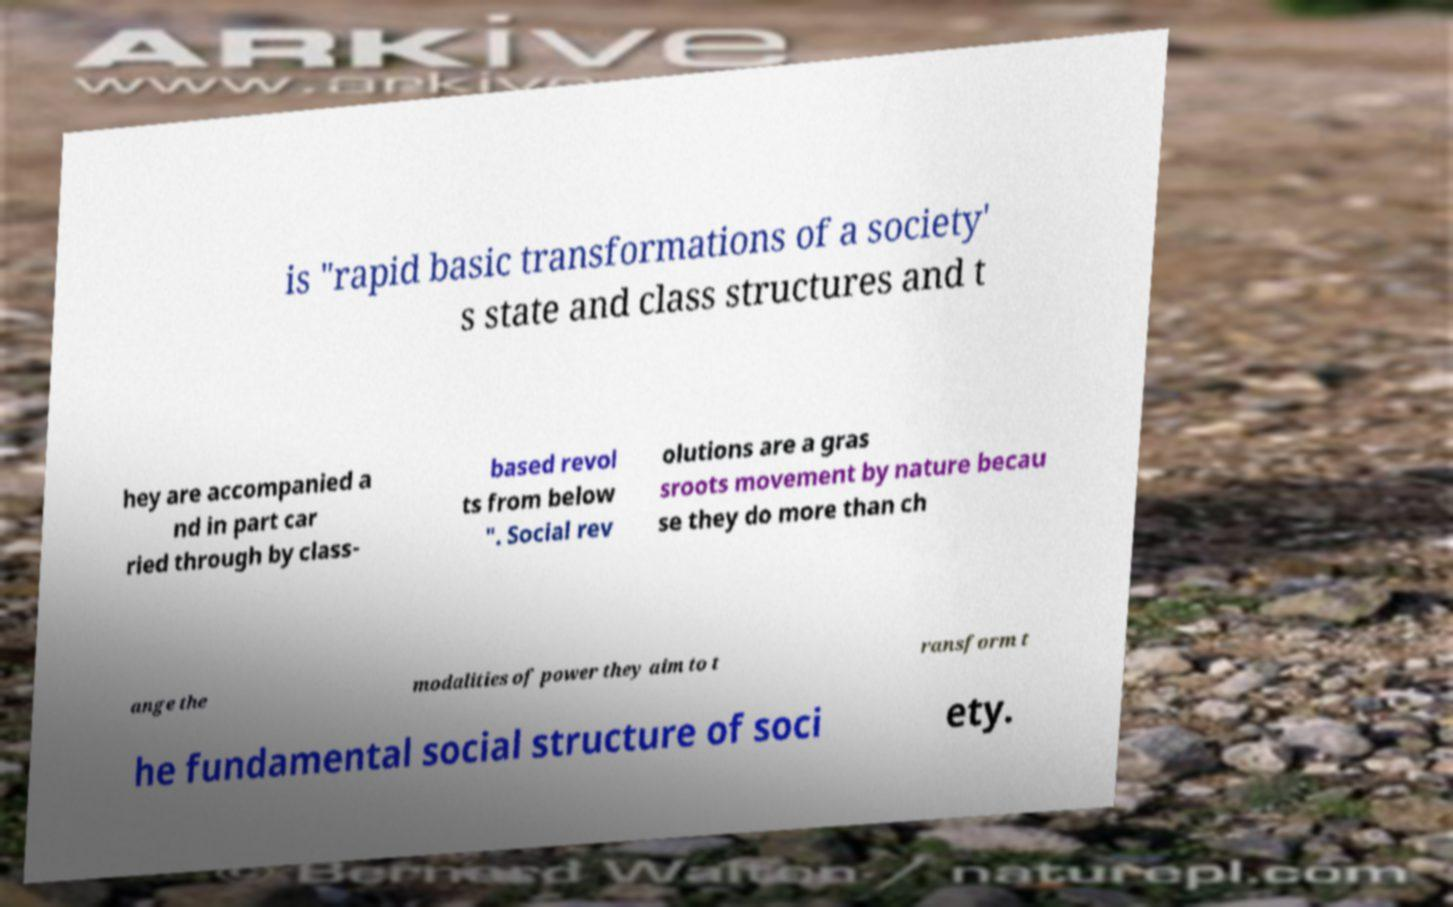Please identify and transcribe the text found in this image. is "rapid basic transformations of a society' s state and class structures and t hey are accompanied a nd in part car ried through by class- based revol ts from below ". Social rev olutions are a gras sroots movement by nature becau se they do more than ch ange the modalities of power they aim to t ransform t he fundamental social structure of soci ety. 